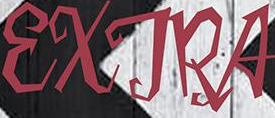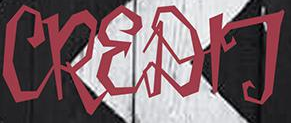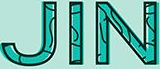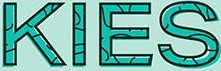What text appears in these images from left to right, separated by a semicolon? EXTRA; CREDIT; JIN; KIES 